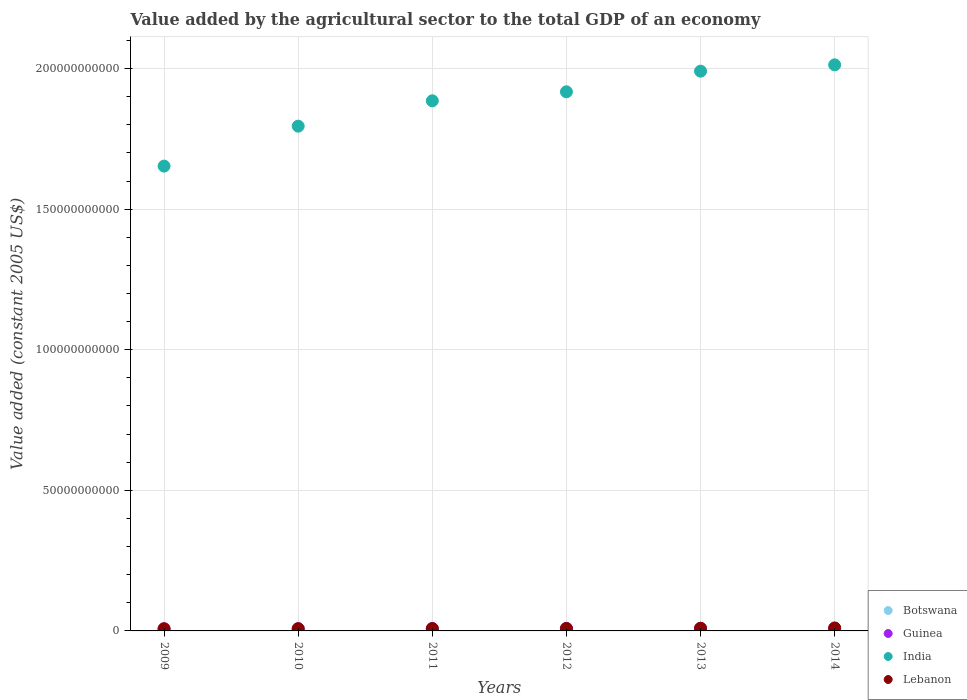How many different coloured dotlines are there?
Offer a terse response. 4. Is the number of dotlines equal to the number of legend labels?
Offer a very short reply. Yes. What is the value added by the agricultural sector in India in 2013?
Offer a very short reply. 1.99e+11. Across all years, what is the maximum value added by the agricultural sector in India?
Offer a very short reply. 2.01e+11. Across all years, what is the minimum value added by the agricultural sector in Guinea?
Make the answer very short. 7.48e+08. In which year was the value added by the agricultural sector in Botswana minimum?
Your response must be concise. 2012. What is the total value added by the agricultural sector in Botswana in the graph?
Provide a short and direct response. 1.52e+09. What is the difference between the value added by the agricultural sector in India in 2010 and that in 2012?
Offer a terse response. -1.22e+1. What is the difference between the value added by the agricultural sector in Botswana in 2011 and the value added by the agricultural sector in Lebanon in 2014?
Your response must be concise. -7.92e+08. What is the average value added by the agricultural sector in Lebanon per year?
Provide a succinct answer. 8.82e+08. In the year 2012, what is the difference between the value added by the agricultural sector in Guinea and value added by the agricultural sector in India?
Provide a short and direct response. -1.91e+11. In how many years, is the value added by the agricultural sector in Guinea greater than 90000000000 US$?
Your answer should be compact. 0. What is the ratio of the value added by the agricultural sector in India in 2011 to that in 2014?
Keep it short and to the point. 0.94. Is the value added by the agricultural sector in Lebanon in 2011 less than that in 2012?
Ensure brevity in your answer.  Yes. Is the difference between the value added by the agricultural sector in Guinea in 2013 and 2014 greater than the difference between the value added by the agricultural sector in India in 2013 and 2014?
Provide a short and direct response. Yes. What is the difference between the highest and the second highest value added by the agricultural sector in Botswana?
Give a very brief answer. 4.64e+05. What is the difference between the highest and the lowest value added by the agricultural sector in Guinea?
Provide a short and direct response. 1.76e+08. Is it the case that in every year, the sum of the value added by the agricultural sector in Guinea and value added by the agricultural sector in India  is greater than the value added by the agricultural sector in Lebanon?
Provide a short and direct response. Yes. Does the value added by the agricultural sector in Lebanon monotonically increase over the years?
Your answer should be very brief. Yes. Is the value added by the agricultural sector in Guinea strictly greater than the value added by the agricultural sector in Botswana over the years?
Offer a very short reply. Yes. How many dotlines are there?
Offer a very short reply. 4. How many years are there in the graph?
Provide a short and direct response. 6. What is the difference between two consecutive major ticks on the Y-axis?
Offer a very short reply. 5.00e+1. Are the values on the major ticks of Y-axis written in scientific E-notation?
Offer a terse response. No. How many legend labels are there?
Your answer should be compact. 4. What is the title of the graph?
Keep it short and to the point. Value added by the agricultural sector to the total GDP of an economy. What is the label or title of the X-axis?
Your answer should be compact. Years. What is the label or title of the Y-axis?
Give a very brief answer. Value added (constant 2005 US$). What is the Value added (constant 2005 US$) of Botswana in 2009?
Your answer should be compact. 2.51e+08. What is the Value added (constant 2005 US$) in Guinea in 2009?
Keep it short and to the point. 7.48e+08. What is the Value added (constant 2005 US$) in India in 2009?
Your answer should be very brief. 1.65e+11. What is the Value added (constant 2005 US$) in Lebanon in 2009?
Offer a terse response. 7.59e+08. What is the Value added (constant 2005 US$) of Botswana in 2010?
Your response must be concise. 2.65e+08. What is the Value added (constant 2005 US$) of Guinea in 2010?
Keep it short and to the point. 7.71e+08. What is the Value added (constant 2005 US$) in India in 2010?
Make the answer very short. 1.80e+11. What is the Value added (constant 2005 US$) in Lebanon in 2010?
Offer a very short reply. 7.92e+08. What is the Value added (constant 2005 US$) of Botswana in 2011?
Keep it short and to the point. 2.66e+08. What is the Value added (constant 2005 US$) of Guinea in 2011?
Your response must be concise. 8.07e+08. What is the Value added (constant 2005 US$) of India in 2011?
Give a very brief answer. 1.89e+11. What is the Value added (constant 2005 US$) of Lebanon in 2011?
Provide a succinct answer. 8.47e+08. What is the Value added (constant 2005 US$) in Botswana in 2012?
Ensure brevity in your answer.  2.43e+08. What is the Value added (constant 2005 US$) of Guinea in 2012?
Your response must be concise. 8.42e+08. What is the Value added (constant 2005 US$) of India in 2012?
Offer a terse response. 1.92e+11. What is the Value added (constant 2005 US$) in Lebanon in 2012?
Provide a succinct answer. 8.88e+08. What is the Value added (constant 2005 US$) in Botswana in 2013?
Give a very brief answer. 2.46e+08. What is the Value added (constant 2005 US$) in Guinea in 2013?
Provide a short and direct response. 9.05e+08. What is the Value added (constant 2005 US$) in India in 2013?
Offer a terse response. 1.99e+11. What is the Value added (constant 2005 US$) in Lebanon in 2013?
Your response must be concise. 9.50e+08. What is the Value added (constant 2005 US$) in Botswana in 2014?
Make the answer very short. 2.45e+08. What is the Value added (constant 2005 US$) in Guinea in 2014?
Provide a succinct answer. 9.24e+08. What is the Value added (constant 2005 US$) of India in 2014?
Offer a terse response. 2.01e+11. What is the Value added (constant 2005 US$) in Lebanon in 2014?
Offer a very short reply. 1.06e+09. Across all years, what is the maximum Value added (constant 2005 US$) in Botswana?
Ensure brevity in your answer.  2.66e+08. Across all years, what is the maximum Value added (constant 2005 US$) of Guinea?
Your response must be concise. 9.24e+08. Across all years, what is the maximum Value added (constant 2005 US$) of India?
Provide a succinct answer. 2.01e+11. Across all years, what is the maximum Value added (constant 2005 US$) of Lebanon?
Your answer should be compact. 1.06e+09. Across all years, what is the minimum Value added (constant 2005 US$) of Botswana?
Provide a short and direct response. 2.43e+08. Across all years, what is the minimum Value added (constant 2005 US$) in Guinea?
Ensure brevity in your answer.  7.48e+08. Across all years, what is the minimum Value added (constant 2005 US$) in India?
Offer a very short reply. 1.65e+11. Across all years, what is the minimum Value added (constant 2005 US$) of Lebanon?
Your answer should be compact. 7.59e+08. What is the total Value added (constant 2005 US$) in Botswana in the graph?
Ensure brevity in your answer.  1.52e+09. What is the total Value added (constant 2005 US$) in Guinea in the graph?
Give a very brief answer. 5.00e+09. What is the total Value added (constant 2005 US$) of India in the graph?
Make the answer very short. 1.13e+12. What is the total Value added (constant 2005 US$) of Lebanon in the graph?
Provide a short and direct response. 5.29e+09. What is the difference between the Value added (constant 2005 US$) in Botswana in 2009 and that in 2010?
Your answer should be very brief. -1.46e+07. What is the difference between the Value added (constant 2005 US$) in Guinea in 2009 and that in 2010?
Offer a terse response. -2.39e+07. What is the difference between the Value added (constant 2005 US$) of India in 2009 and that in 2010?
Offer a terse response. -1.42e+1. What is the difference between the Value added (constant 2005 US$) in Lebanon in 2009 and that in 2010?
Keep it short and to the point. -3.27e+07. What is the difference between the Value added (constant 2005 US$) in Botswana in 2009 and that in 2011?
Ensure brevity in your answer.  -1.50e+07. What is the difference between the Value added (constant 2005 US$) in Guinea in 2009 and that in 2011?
Offer a terse response. -5.98e+07. What is the difference between the Value added (constant 2005 US$) in India in 2009 and that in 2011?
Provide a succinct answer. -2.32e+1. What is the difference between the Value added (constant 2005 US$) of Lebanon in 2009 and that in 2011?
Make the answer very short. -8.83e+07. What is the difference between the Value added (constant 2005 US$) in Botswana in 2009 and that in 2012?
Offer a very short reply. 7.62e+06. What is the difference between the Value added (constant 2005 US$) in Guinea in 2009 and that in 2012?
Give a very brief answer. -9.49e+07. What is the difference between the Value added (constant 2005 US$) of India in 2009 and that in 2012?
Your answer should be compact. -2.64e+1. What is the difference between the Value added (constant 2005 US$) of Lebanon in 2009 and that in 2012?
Your answer should be very brief. -1.29e+08. What is the difference between the Value added (constant 2005 US$) in Botswana in 2009 and that in 2013?
Give a very brief answer. 4.40e+06. What is the difference between the Value added (constant 2005 US$) in Guinea in 2009 and that in 2013?
Ensure brevity in your answer.  -1.57e+08. What is the difference between the Value added (constant 2005 US$) in India in 2009 and that in 2013?
Your answer should be compact. -3.38e+1. What is the difference between the Value added (constant 2005 US$) of Lebanon in 2009 and that in 2013?
Offer a very short reply. -1.91e+08. What is the difference between the Value added (constant 2005 US$) of Botswana in 2009 and that in 2014?
Keep it short and to the point. 5.26e+06. What is the difference between the Value added (constant 2005 US$) of Guinea in 2009 and that in 2014?
Make the answer very short. -1.76e+08. What is the difference between the Value added (constant 2005 US$) of India in 2009 and that in 2014?
Give a very brief answer. -3.60e+1. What is the difference between the Value added (constant 2005 US$) in Lebanon in 2009 and that in 2014?
Give a very brief answer. -2.99e+08. What is the difference between the Value added (constant 2005 US$) in Botswana in 2010 and that in 2011?
Keep it short and to the point. -4.64e+05. What is the difference between the Value added (constant 2005 US$) in Guinea in 2010 and that in 2011?
Your response must be concise. -3.59e+07. What is the difference between the Value added (constant 2005 US$) of India in 2010 and that in 2011?
Your response must be concise. -9.01e+09. What is the difference between the Value added (constant 2005 US$) of Lebanon in 2010 and that in 2011?
Ensure brevity in your answer.  -5.56e+07. What is the difference between the Value added (constant 2005 US$) in Botswana in 2010 and that in 2012?
Offer a very short reply. 2.22e+07. What is the difference between the Value added (constant 2005 US$) in Guinea in 2010 and that in 2012?
Provide a succinct answer. -7.10e+07. What is the difference between the Value added (constant 2005 US$) of India in 2010 and that in 2012?
Your response must be concise. -1.22e+1. What is the difference between the Value added (constant 2005 US$) of Lebanon in 2010 and that in 2012?
Give a very brief answer. -9.65e+07. What is the difference between the Value added (constant 2005 US$) in Botswana in 2010 and that in 2013?
Keep it short and to the point. 1.90e+07. What is the difference between the Value added (constant 2005 US$) in Guinea in 2010 and that in 2013?
Ensure brevity in your answer.  -1.34e+08. What is the difference between the Value added (constant 2005 US$) in India in 2010 and that in 2013?
Keep it short and to the point. -1.96e+1. What is the difference between the Value added (constant 2005 US$) in Lebanon in 2010 and that in 2013?
Offer a very short reply. -1.59e+08. What is the difference between the Value added (constant 2005 US$) in Botswana in 2010 and that in 2014?
Provide a succinct answer. 1.98e+07. What is the difference between the Value added (constant 2005 US$) in Guinea in 2010 and that in 2014?
Make the answer very short. -1.52e+08. What is the difference between the Value added (constant 2005 US$) in India in 2010 and that in 2014?
Provide a succinct answer. -2.18e+1. What is the difference between the Value added (constant 2005 US$) of Lebanon in 2010 and that in 2014?
Your response must be concise. -2.66e+08. What is the difference between the Value added (constant 2005 US$) of Botswana in 2011 and that in 2012?
Offer a very short reply. 2.27e+07. What is the difference between the Value added (constant 2005 US$) of Guinea in 2011 and that in 2012?
Your answer should be very brief. -3.51e+07. What is the difference between the Value added (constant 2005 US$) in India in 2011 and that in 2012?
Give a very brief answer. -3.20e+09. What is the difference between the Value added (constant 2005 US$) of Lebanon in 2011 and that in 2012?
Give a very brief answer. -4.08e+07. What is the difference between the Value added (constant 2005 US$) of Botswana in 2011 and that in 2013?
Give a very brief answer. 1.94e+07. What is the difference between the Value added (constant 2005 US$) of Guinea in 2011 and that in 2013?
Keep it short and to the point. -9.76e+07. What is the difference between the Value added (constant 2005 US$) of India in 2011 and that in 2013?
Keep it short and to the point. -1.05e+1. What is the difference between the Value added (constant 2005 US$) in Lebanon in 2011 and that in 2013?
Offer a very short reply. -1.03e+08. What is the difference between the Value added (constant 2005 US$) of Botswana in 2011 and that in 2014?
Offer a terse response. 2.03e+07. What is the difference between the Value added (constant 2005 US$) in Guinea in 2011 and that in 2014?
Your response must be concise. -1.17e+08. What is the difference between the Value added (constant 2005 US$) of India in 2011 and that in 2014?
Provide a short and direct response. -1.28e+1. What is the difference between the Value added (constant 2005 US$) in Lebanon in 2011 and that in 2014?
Offer a terse response. -2.10e+08. What is the difference between the Value added (constant 2005 US$) in Botswana in 2012 and that in 2013?
Offer a terse response. -3.22e+06. What is the difference between the Value added (constant 2005 US$) of Guinea in 2012 and that in 2013?
Give a very brief answer. -6.25e+07. What is the difference between the Value added (constant 2005 US$) of India in 2012 and that in 2013?
Provide a succinct answer. -7.34e+09. What is the difference between the Value added (constant 2005 US$) in Lebanon in 2012 and that in 2013?
Your answer should be compact. -6.22e+07. What is the difference between the Value added (constant 2005 US$) of Botswana in 2012 and that in 2014?
Your response must be concise. -2.37e+06. What is the difference between the Value added (constant 2005 US$) of Guinea in 2012 and that in 2014?
Offer a very short reply. -8.14e+07. What is the difference between the Value added (constant 2005 US$) of India in 2012 and that in 2014?
Offer a very short reply. -9.59e+09. What is the difference between the Value added (constant 2005 US$) of Lebanon in 2012 and that in 2014?
Provide a succinct answer. -1.69e+08. What is the difference between the Value added (constant 2005 US$) in Botswana in 2013 and that in 2014?
Keep it short and to the point. 8.58e+05. What is the difference between the Value added (constant 2005 US$) in Guinea in 2013 and that in 2014?
Your answer should be compact. -1.89e+07. What is the difference between the Value added (constant 2005 US$) in India in 2013 and that in 2014?
Your response must be concise. -2.25e+09. What is the difference between the Value added (constant 2005 US$) in Lebanon in 2013 and that in 2014?
Provide a succinct answer. -1.07e+08. What is the difference between the Value added (constant 2005 US$) of Botswana in 2009 and the Value added (constant 2005 US$) of Guinea in 2010?
Provide a succinct answer. -5.21e+08. What is the difference between the Value added (constant 2005 US$) in Botswana in 2009 and the Value added (constant 2005 US$) in India in 2010?
Provide a succinct answer. -1.79e+11. What is the difference between the Value added (constant 2005 US$) of Botswana in 2009 and the Value added (constant 2005 US$) of Lebanon in 2010?
Provide a short and direct response. -5.41e+08. What is the difference between the Value added (constant 2005 US$) in Guinea in 2009 and the Value added (constant 2005 US$) in India in 2010?
Make the answer very short. -1.79e+11. What is the difference between the Value added (constant 2005 US$) of Guinea in 2009 and the Value added (constant 2005 US$) of Lebanon in 2010?
Your response must be concise. -4.41e+07. What is the difference between the Value added (constant 2005 US$) of India in 2009 and the Value added (constant 2005 US$) of Lebanon in 2010?
Provide a short and direct response. 1.65e+11. What is the difference between the Value added (constant 2005 US$) of Botswana in 2009 and the Value added (constant 2005 US$) of Guinea in 2011?
Keep it short and to the point. -5.57e+08. What is the difference between the Value added (constant 2005 US$) of Botswana in 2009 and the Value added (constant 2005 US$) of India in 2011?
Your answer should be very brief. -1.88e+11. What is the difference between the Value added (constant 2005 US$) of Botswana in 2009 and the Value added (constant 2005 US$) of Lebanon in 2011?
Provide a short and direct response. -5.97e+08. What is the difference between the Value added (constant 2005 US$) in Guinea in 2009 and the Value added (constant 2005 US$) in India in 2011?
Offer a very short reply. -1.88e+11. What is the difference between the Value added (constant 2005 US$) in Guinea in 2009 and the Value added (constant 2005 US$) in Lebanon in 2011?
Provide a short and direct response. -9.97e+07. What is the difference between the Value added (constant 2005 US$) of India in 2009 and the Value added (constant 2005 US$) of Lebanon in 2011?
Offer a terse response. 1.64e+11. What is the difference between the Value added (constant 2005 US$) in Botswana in 2009 and the Value added (constant 2005 US$) in Guinea in 2012?
Provide a succinct answer. -5.92e+08. What is the difference between the Value added (constant 2005 US$) in Botswana in 2009 and the Value added (constant 2005 US$) in India in 2012?
Offer a terse response. -1.91e+11. What is the difference between the Value added (constant 2005 US$) in Botswana in 2009 and the Value added (constant 2005 US$) in Lebanon in 2012?
Your response must be concise. -6.38e+08. What is the difference between the Value added (constant 2005 US$) of Guinea in 2009 and the Value added (constant 2005 US$) of India in 2012?
Offer a terse response. -1.91e+11. What is the difference between the Value added (constant 2005 US$) in Guinea in 2009 and the Value added (constant 2005 US$) in Lebanon in 2012?
Your answer should be very brief. -1.41e+08. What is the difference between the Value added (constant 2005 US$) in India in 2009 and the Value added (constant 2005 US$) in Lebanon in 2012?
Ensure brevity in your answer.  1.64e+11. What is the difference between the Value added (constant 2005 US$) of Botswana in 2009 and the Value added (constant 2005 US$) of Guinea in 2013?
Keep it short and to the point. -6.54e+08. What is the difference between the Value added (constant 2005 US$) of Botswana in 2009 and the Value added (constant 2005 US$) of India in 2013?
Keep it short and to the point. -1.99e+11. What is the difference between the Value added (constant 2005 US$) in Botswana in 2009 and the Value added (constant 2005 US$) in Lebanon in 2013?
Your answer should be very brief. -7.00e+08. What is the difference between the Value added (constant 2005 US$) of Guinea in 2009 and the Value added (constant 2005 US$) of India in 2013?
Ensure brevity in your answer.  -1.98e+11. What is the difference between the Value added (constant 2005 US$) of Guinea in 2009 and the Value added (constant 2005 US$) of Lebanon in 2013?
Make the answer very short. -2.03e+08. What is the difference between the Value added (constant 2005 US$) in India in 2009 and the Value added (constant 2005 US$) in Lebanon in 2013?
Offer a terse response. 1.64e+11. What is the difference between the Value added (constant 2005 US$) in Botswana in 2009 and the Value added (constant 2005 US$) in Guinea in 2014?
Offer a terse response. -6.73e+08. What is the difference between the Value added (constant 2005 US$) of Botswana in 2009 and the Value added (constant 2005 US$) of India in 2014?
Offer a terse response. -2.01e+11. What is the difference between the Value added (constant 2005 US$) in Botswana in 2009 and the Value added (constant 2005 US$) in Lebanon in 2014?
Your answer should be compact. -8.07e+08. What is the difference between the Value added (constant 2005 US$) of Guinea in 2009 and the Value added (constant 2005 US$) of India in 2014?
Your answer should be very brief. -2.01e+11. What is the difference between the Value added (constant 2005 US$) in Guinea in 2009 and the Value added (constant 2005 US$) in Lebanon in 2014?
Provide a short and direct response. -3.10e+08. What is the difference between the Value added (constant 2005 US$) of India in 2009 and the Value added (constant 2005 US$) of Lebanon in 2014?
Your response must be concise. 1.64e+11. What is the difference between the Value added (constant 2005 US$) in Botswana in 2010 and the Value added (constant 2005 US$) in Guinea in 2011?
Your response must be concise. -5.42e+08. What is the difference between the Value added (constant 2005 US$) in Botswana in 2010 and the Value added (constant 2005 US$) in India in 2011?
Provide a succinct answer. -1.88e+11. What is the difference between the Value added (constant 2005 US$) in Botswana in 2010 and the Value added (constant 2005 US$) in Lebanon in 2011?
Make the answer very short. -5.82e+08. What is the difference between the Value added (constant 2005 US$) in Guinea in 2010 and the Value added (constant 2005 US$) in India in 2011?
Offer a very short reply. -1.88e+11. What is the difference between the Value added (constant 2005 US$) in Guinea in 2010 and the Value added (constant 2005 US$) in Lebanon in 2011?
Your answer should be compact. -7.58e+07. What is the difference between the Value added (constant 2005 US$) in India in 2010 and the Value added (constant 2005 US$) in Lebanon in 2011?
Your response must be concise. 1.79e+11. What is the difference between the Value added (constant 2005 US$) of Botswana in 2010 and the Value added (constant 2005 US$) of Guinea in 2012?
Offer a terse response. -5.77e+08. What is the difference between the Value added (constant 2005 US$) in Botswana in 2010 and the Value added (constant 2005 US$) in India in 2012?
Provide a short and direct response. -1.91e+11. What is the difference between the Value added (constant 2005 US$) in Botswana in 2010 and the Value added (constant 2005 US$) in Lebanon in 2012?
Offer a terse response. -6.23e+08. What is the difference between the Value added (constant 2005 US$) of Guinea in 2010 and the Value added (constant 2005 US$) of India in 2012?
Your answer should be very brief. -1.91e+11. What is the difference between the Value added (constant 2005 US$) of Guinea in 2010 and the Value added (constant 2005 US$) of Lebanon in 2012?
Give a very brief answer. -1.17e+08. What is the difference between the Value added (constant 2005 US$) in India in 2010 and the Value added (constant 2005 US$) in Lebanon in 2012?
Your response must be concise. 1.79e+11. What is the difference between the Value added (constant 2005 US$) of Botswana in 2010 and the Value added (constant 2005 US$) of Guinea in 2013?
Offer a terse response. -6.40e+08. What is the difference between the Value added (constant 2005 US$) in Botswana in 2010 and the Value added (constant 2005 US$) in India in 2013?
Provide a short and direct response. -1.99e+11. What is the difference between the Value added (constant 2005 US$) in Botswana in 2010 and the Value added (constant 2005 US$) in Lebanon in 2013?
Your answer should be compact. -6.85e+08. What is the difference between the Value added (constant 2005 US$) of Guinea in 2010 and the Value added (constant 2005 US$) of India in 2013?
Ensure brevity in your answer.  -1.98e+11. What is the difference between the Value added (constant 2005 US$) in Guinea in 2010 and the Value added (constant 2005 US$) in Lebanon in 2013?
Offer a very short reply. -1.79e+08. What is the difference between the Value added (constant 2005 US$) of India in 2010 and the Value added (constant 2005 US$) of Lebanon in 2013?
Provide a succinct answer. 1.79e+11. What is the difference between the Value added (constant 2005 US$) of Botswana in 2010 and the Value added (constant 2005 US$) of Guinea in 2014?
Ensure brevity in your answer.  -6.59e+08. What is the difference between the Value added (constant 2005 US$) of Botswana in 2010 and the Value added (constant 2005 US$) of India in 2014?
Your answer should be very brief. -2.01e+11. What is the difference between the Value added (constant 2005 US$) of Botswana in 2010 and the Value added (constant 2005 US$) of Lebanon in 2014?
Your response must be concise. -7.92e+08. What is the difference between the Value added (constant 2005 US$) of Guinea in 2010 and the Value added (constant 2005 US$) of India in 2014?
Your answer should be very brief. -2.01e+11. What is the difference between the Value added (constant 2005 US$) of Guinea in 2010 and the Value added (constant 2005 US$) of Lebanon in 2014?
Offer a very short reply. -2.86e+08. What is the difference between the Value added (constant 2005 US$) in India in 2010 and the Value added (constant 2005 US$) in Lebanon in 2014?
Provide a short and direct response. 1.78e+11. What is the difference between the Value added (constant 2005 US$) of Botswana in 2011 and the Value added (constant 2005 US$) of Guinea in 2012?
Ensure brevity in your answer.  -5.77e+08. What is the difference between the Value added (constant 2005 US$) in Botswana in 2011 and the Value added (constant 2005 US$) in India in 2012?
Your answer should be compact. -1.91e+11. What is the difference between the Value added (constant 2005 US$) in Botswana in 2011 and the Value added (constant 2005 US$) in Lebanon in 2012?
Keep it short and to the point. -6.23e+08. What is the difference between the Value added (constant 2005 US$) of Guinea in 2011 and the Value added (constant 2005 US$) of India in 2012?
Your answer should be very brief. -1.91e+11. What is the difference between the Value added (constant 2005 US$) of Guinea in 2011 and the Value added (constant 2005 US$) of Lebanon in 2012?
Give a very brief answer. -8.08e+07. What is the difference between the Value added (constant 2005 US$) in India in 2011 and the Value added (constant 2005 US$) in Lebanon in 2012?
Give a very brief answer. 1.88e+11. What is the difference between the Value added (constant 2005 US$) of Botswana in 2011 and the Value added (constant 2005 US$) of Guinea in 2013?
Give a very brief answer. -6.39e+08. What is the difference between the Value added (constant 2005 US$) of Botswana in 2011 and the Value added (constant 2005 US$) of India in 2013?
Make the answer very short. -1.99e+11. What is the difference between the Value added (constant 2005 US$) in Botswana in 2011 and the Value added (constant 2005 US$) in Lebanon in 2013?
Make the answer very short. -6.85e+08. What is the difference between the Value added (constant 2005 US$) of Guinea in 2011 and the Value added (constant 2005 US$) of India in 2013?
Your response must be concise. -1.98e+11. What is the difference between the Value added (constant 2005 US$) of Guinea in 2011 and the Value added (constant 2005 US$) of Lebanon in 2013?
Make the answer very short. -1.43e+08. What is the difference between the Value added (constant 2005 US$) of India in 2011 and the Value added (constant 2005 US$) of Lebanon in 2013?
Your response must be concise. 1.88e+11. What is the difference between the Value added (constant 2005 US$) in Botswana in 2011 and the Value added (constant 2005 US$) in Guinea in 2014?
Offer a terse response. -6.58e+08. What is the difference between the Value added (constant 2005 US$) of Botswana in 2011 and the Value added (constant 2005 US$) of India in 2014?
Make the answer very short. -2.01e+11. What is the difference between the Value added (constant 2005 US$) in Botswana in 2011 and the Value added (constant 2005 US$) in Lebanon in 2014?
Your answer should be very brief. -7.92e+08. What is the difference between the Value added (constant 2005 US$) of Guinea in 2011 and the Value added (constant 2005 US$) of India in 2014?
Your answer should be compact. -2.01e+11. What is the difference between the Value added (constant 2005 US$) of Guinea in 2011 and the Value added (constant 2005 US$) of Lebanon in 2014?
Your answer should be compact. -2.50e+08. What is the difference between the Value added (constant 2005 US$) in India in 2011 and the Value added (constant 2005 US$) in Lebanon in 2014?
Offer a terse response. 1.87e+11. What is the difference between the Value added (constant 2005 US$) of Botswana in 2012 and the Value added (constant 2005 US$) of Guinea in 2013?
Provide a succinct answer. -6.62e+08. What is the difference between the Value added (constant 2005 US$) of Botswana in 2012 and the Value added (constant 2005 US$) of India in 2013?
Make the answer very short. -1.99e+11. What is the difference between the Value added (constant 2005 US$) in Botswana in 2012 and the Value added (constant 2005 US$) in Lebanon in 2013?
Your response must be concise. -7.07e+08. What is the difference between the Value added (constant 2005 US$) of Guinea in 2012 and the Value added (constant 2005 US$) of India in 2013?
Provide a short and direct response. -1.98e+11. What is the difference between the Value added (constant 2005 US$) of Guinea in 2012 and the Value added (constant 2005 US$) of Lebanon in 2013?
Offer a terse response. -1.08e+08. What is the difference between the Value added (constant 2005 US$) in India in 2012 and the Value added (constant 2005 US$) in Lebanon in 2013?
Your response must be concise. 1.91e+11. What is the difference between the Value added (constant 2005 US$) in Botswana in 2012 and the Value added (constant 2005 US$) in Guinea in 2014?
Your answer should be very brief. -6.81e+08. What is the difference between the Value added (constant 2005 US$) in Botswana in 2012 and the Value added (constant 2005 US$) in India in 2014?
Provide a succinct answer. -2.01e+11. What is the difference between the Value added (constant 2005 US$) of Botswana in 2012 and the Value added (constant 2005 US$) of Lebanon in 2014?
Provide a succinct answer. -8.15e+08. What is the difference between the Value added (constant 2005 US$) in Guinea in 2012 and the Value added (constant 2005 US$) in India in 2014?
Provide a short and direct response. -2.00e+11. What is the difference between the Value added (constant 2005 US$) in Guinea in 2012 and the Value added (constant 2005 US$) in Lebanon in 2014?
Provide a short and direct response. -2.15e+08. What is the difference between the Value added (constant 2005 US$) in India in 2012 and the Value added (constant 2005 US$) in Lebanon in 2014?
Your response must be concise. 1.91e+11. What is the difference between the Value added (constant 2005 US$) of Botswana in 2013 and the Value added (constant 2005 US$) of Guinea in 2014?
Your response must be concise. -6.78e+08. What is the difference between the Value added (constant 2005 US$) in Botswana in 2013 and the Value added (constant 2005 US$) in India in 2014?
Your answer should be very brief. -2.01e+11. What is the difference between the Value added (constant 2005 US$) of Botswana in 2013 and the Value added (constant 2005 US$) of Lebanon in 2014?
Your answer should be very brief. -8.11e+08. What is the difference between the Value added (constant 2005 US$) in Guinea in 2013 and the Value added (constant 2005 US$) in India in 2014?
Keep it short and to the point. -2.00e+11. What is the difference between the Value added (constant 2005 US$) of Guinea in 2013 and the Value added (constant 2005 US$) of Lebanon in 2014?
Provide a short and direct response. -1.53e+08. What is the difference between the Value added (constant 2005 US$) of India in 2013 and the Value added (constant 2005 US$) of Lebanon in 2014?
Give a very brief answer. 1.98e+11. What is the average Value added (constant 2005 US$) of Botswana per year?
Give a very brief answer. 2.53e+08. What is the average Value added (constant 2005 US$) of Guinea per year?
Make the answer very short. 8.33e+08. What is the average Value added (constant 2005 US$) in India per year?
Keep it short and to the point. 1.88e+11. What is the average Value added (constant 2005 US$) in Lebanon per year?
Your answer should be very brief. 8.82e+08. In the year 2009, what is the difference between the Value added (constant 2005 US$) in Botswana and Value added (constant 2005 US$) in Guinea?
Your answer should be compact. -4.97e+08. In the year 2009, what is the difference between the Value added (constant 2005 US$) of Botswana and Value added (constant 2005 US$) of India?
Your response must be concise. -1.65e+11. In the year 2009, what is the difference between the Value added (constant 2005 US$) in Botswana and Value added (constant 2005 US$) in Lebanon?
Ensure brevity in your answer.  -5.08e+08. In the year 2009, what is the difference between the Value added (constant 2005 US$) in Guinea and Value added (constant 2005 US$) in India?
Provide a succinct answer. -1.65e+11. In the year 2009, what is the difference between the Value added (constant 2005 US$) of Guinea and Value added (constant 2005 US$) of Lebanon?
Offer a terse response. -1.14e+07. In the year 2009, what is the difference between the Value added (constant 2005 US$) in India and Value added (constant 2005 US$) in Lebanon?
Give a very brief answer. 1.65e+11. In the year 2010, what is the difference between the Value added (constant 2005 US$) in Botswana and Value added (constant 2005 US$) in Guinea?
Your response must be concise. -5.06e+08. In the year 2010, what is the difference between the Value added (constant 2005 US$) in Botswana and Value added (constant 2005 US$) in India?
Your answer should be compact. -1.79e+11. In the year 2010, what is the difference between the Value added (constant 2005 US$) in Botswana and Value added (constant 2005 US$) in Lebanon?
Make the answer very short. -5.27e+08. In the year 2010, what is the difference between the Value added (constant 2005 US$) in Guinea and Value added (constant 2005 US$) in India?
Provide a short and direct response. -1.79e+11. In the year 2010, what is the difference between the Value added (constant 2005 US$) of Guinea and Value added (constant 2005 US$) of Lebanon?
Provide a succinct answer. -2.02e+07. In the year 2010, what is the difference between the Value added (constant 2005 US$) of India and Value added (constant 2005 US$) of Lebanon?
Provide a succinct answer. 1.79e+11. In the year 2011, what is the difference between the Value added (constant 2005 US$) of Botswana and Value added (constant 2005 US$) of Guinea?
Your answer should be very brief. -5.42e+08. In the year 2011, what is the difference between the Value added (constant 2005 US$) of Botswana and Value added (constant 2005 US$) of India?
Ensure brevity in your answer.  -1.88e+11. In the year 2011, what is the difference between the Value added (constant 2005 US$) of Botswana and Value added (constant 2005 US$) of Lebanon?
Your answer should be compact. -5.82e+08. In the year 2011, what is the difference between the Value added (constant 2005 US$) of Guinea and Value added (constant 2005 US$) of India?
Your answer should be very brief. -1.88e+11. In the year 2011, what is the difference between the Value added (constant 2005 US$) in Guinea and Value added (constant 2005 US$) in Lebanon?
Make the answer very short. -3.99e+07. In the year 2011, what is the difference between the Value added (constant 2005 US$) of India and Value added (constant 2005 US$) of Lebanon?
Give a very brief answer. 1.88e+11. In the year 2012, what is the difference between the Value added (constant 2005 US$) in Botswana and Value added (constant 2005 US$) in Guinea?
Your answer should be very brief. -6.00e+08. In the year 2012, what is the difference between the Value added (constant 2005 US$) in Botswana and Value added (constant 2005 US$) in India?
Provide a succinct answer. -1.91e+11. In the year 2012, what is the difference between the Value added (constant 2005 US$) of Botswana and Value added (constant 2005 US$) of Lebanon?
Provide a short and direct response. -6.45e+08. In the year 2012, what is the difference between the Value added (constant 2005 US$) in Guinea and Value added (constant 2005 US$) in India?
Provide a succinct answer. -1.91e+11. In the year 2012, what is the difference between the Value added (constant 2005 US$) in Guinea and Value added (constant 2005 US$) in Lebanon?
Your response must be concise. -4.57e+07. In the year 2012, what is the difference between the Value added (constant 2005 US$) in India and Value added (constant 2005 US$) in Lebanon?
Your answer should be compact. 1.91e+11. In the year 2013, what is the difference between the Value added (constant 2005 US$) of Botswana and Value added (constant 2005 US$) of Guinea?
Make the answer very short. -6.59e+08. In the year 2013, what is the difference between the Value added (constant 2005 US$) in Botswana and Value added (constant 2005 US$) in India?
Keep it short and to the point. -1.99e+11. In the year 2013, what is the difference between the Value added (constant 2005 US$) of Botswana and Value added (constant 2005 US$) of Lebanon?
Give a very brief answer. -7.04e+08. In the year 2013, what is the difference between the Value added (constant 2005 US$) of Guinea and Value added (constant 2005 US$) of India?
Provide a short and direct response. -1.98e+11. In the year 2013, what is the difference between the Value added (constant 2005 US$) in Guinea and Value added (constant 2005 US$) in Lebanon?
Your response must be concise. -4.53e+07. In the year 2013, what is the difference between the Value added (constant 2005 US$) of India and Value added (constant 2005 US$) of Lebanon?
Your answer should be compact. 1.98e+11. In the year 2014, what is the difference between the Value added (constant 2005 US$) in Botswana and Value added (constant 2005 US$) in Guinea?
Give a very brief answer. -6.79e+08. In the year 2014, what is the difference between the Value added (constant 2005 US$) in Botswana and Value added (constant 2005 US$) in India?
Offer a terse response. -2.01e+11. In the year 2014, what is the difference between the Value added (constant 2005 US$) in Botswana and Value added (constant 2005 US$) in Lebanon?
Your answer should be compact. -8.12e+08. In the year 2014, what is the difference between the Value added (constant 2005 US$) in Guinea and Value added (constant 2005 US$) in India?
Offer a very short reply. -2.00e+11. In the year 2014, what is the difference between the Value added (constant 2005 US$) of Guinea and Value added (constant 2005 US$) of Lebanon?
Provide a succinct answer. -1.34e+08. In the year 2014, what is the difference between the Value added (constant 2005 US$) of India and Value added (constant 2005 US$) of Lebanon?
Keep it short and to the point. 2.00e+11. What is the ratio of the Value added (constant 2005 US$) of Botswana in 2009 to that in 2010?
Offer a very short reply. 0.94. What is the ratio of the Value added (constant 2005 US$) of Guinea in 2009 to that in 2010?
Make the answer very short. 0.97. What is the ratio of the Value added (constant 2005 US$) of India in 2009 to that in 2010?
Your answer should be compact. 0.92. What is the ratio of the Value added (constant 2005 US$) in Lebanon in 2009 to that in 2010?
Provide a succinct answer. 0.96. What is the ratio of the Value added (constant 2005 US$) of Botswana in 2009 to that in 2011?
Offer a very short reply. 0.94. What is the ratio of the Value added (constant 2005 US$) in Guinea in 2009 to that in 2011?
Give a very brief answer. 0.93. What is the ratio of the Value added (constant 2005 US$) of India in 2009 to that in 2011?
Make the answer very short. 0.88. What is the ratio of the Value added (constant 2005 US$) in Lebanon in 2009 to that in 2011?
Provide a short and direct response. 0.9. What is the ratio of the Value added (constant 2005 US$) of Botswana in 2009 to that in 2012?
Provide a succinct answer. 1.03. What is the ratio of the Value added (constant 2005 US$) of Guinea in 2009 to that in 2012?
Ensure brevity in your answer.  0.89. What is the ratio of the Value added (constant 2005 US$) in India in 2009 to that in 2012?
Make the answer very short. 0.86. What is the ratio of the Value added (constant 2005 US$) in Lebanon in 2009 to that in 2012?
Offer a terse response. 0.85. What is the ratio of the Value added (constant 2005 US$) of Botswana in 2009 to that in 2013?
Make the answer very short. 1.02. What is the ratio of the Value added (constant 2005 US$) of Guinea in 2009 to that in 2013?
Make the answer very short. 0.83. What is the ratio of the Value added (constant 2005 US$) of India in 2009 to that in 2013?
Ensure brevity in your answer.  0.83. What is the ratio of the Value added (constant 2005 US$) in Lebanon in 2009 to that in 2013?
Your answer should be compact. 0.8. What is the ratio of the Value added (constant 2005 US$) of Botswana in 2009 to that in 2014?
Provide a short and direct response. 1.02. What is the ratio of the Value added (constant 2005 US$) in Guinea in 2009 to that in 2014?
Keep it short and to the point. 0.81. What is the ratio of the Value added (constant 2005 US$) of India in 2009 to that in 2014?
Provide a short and direct response. 0.82. What is the ratio of the Value added (constant 2005 US$) in Lebanon in 2009 to that in 2014?
Give a very brief answer. 0.72. What is the ratio of the Value added (constant 2005 US$) in Botswana in 2010 to that in 2011?
Offer a very short reply. 1. What is the ratio of the Value added (constant 2005 US$) of Guinea in 2010 to that in 2011?
Offer a very short reply. 0.96. What is the ratio of the Value added (constant 2005 US$) in India in 2010 to that in 2011?
Offer a terse response. 0.95. What is the ratio of the Value added (constant 2005 US$) in Lebanon in 2010 to that in 2011?
Provide a succinct answer. 0.93. What is the ratio of the Value added (constant 2005 US$) in Botswana in 2010 to that in 2012?
Your answer should be very brief. 1.09. What is the ratio of the Value added (constant 2005 US$) of Guinea in 2010 to that in 2012?
Provide a succinct answer. 0.92. What is the ratio of the Value added (constant 2005 US$) in India in 2010 to that in 2012?
Keep it short and to the point. 0.94. What is the ratio of the Value added (constant 2005 US$) in Lebanon in 2010 to that in 2012?
Make the answer very short. 0.89. What is the ratio of the Value added (constant 2005 US$) of Botswana in 2010 to that in 2013?
Your answer should be very brief. 1.08. What is the ratio of the Value added (constant 2005 US$) of Guinea in 2010 to that in 2013?
Your answer should be very brief. 0.85. What is the ratio of the Value added (constant 2005 US$) of India in 2010 to that in 2013?
Provide a short and direct response. 0.9. What is the ratio of the Value added (constant 2005 US$) of Lebanon in 2010 to that in 2013?
Keep it short and to the point. 0.83. What is the ratio of the Value added (constant 2005 US$) in Botswana in 2010 to that in 2014?
Provide a short and direct response. 1.08. What is the ratio of the Value added (constant 2005 US$) of Guinea in 2010 to that in 2014?
Give a very brief answer. 0.83. What is the ratio of the Value added (constant 2005 US$) of India in 2010 to that in 2014?
Provide a succinct answer. 0.89. What is the ratio of the Value added (constant 2005 US$) in Lebanon in 2010 to that in 2014?
Your response must be concise. 0.75. What is the ratio of the Value added (constant 2005 US$) of Botswana in 2011 to that in 2012?
Offer a terse response. 1.09. What is the ratio of the Value added (constant 2005 US$) of India in 2011 to that in 2012?
Your answer should be very brief. 0.98. What is the ratio of the Value added (constant 2005 US$) of Lebanon in 2011 to that in 2012?
Your answer should be compact. 0.95. What is the ratio of the Value added (constant 2005 US$) of Botswana in 2011 to that in 2013?
Your answer should be very brief. 1.08. What is the ratio of the Value added (constant 2005 US$) in Guinea in 2011 to that in 2013?
Provide a succinct answer. 0.89. What is the ratio of the Value added (constant 2005 US$) in India in 2011 to that in 2013?
Provide a short and direct response. 0.95. What is the ratio of the Value added (constant 2005 US$) of Lebanon in 2011 to that in 2013?
Offer a very short reply. 0.89. What is the ratio of the Value added (constant 2005 US$) of Botswana in 2011 to that in 2014?
Provide a short and direct response. 1.08. What is the ratio of the Value added (constant 2005 US$) in Guinea in 2011 to that in 2014?
Provide a succinct answer. 0.87. What is the ratio of the Value added (constant 2005 US$) in India in 2011 to that in 2014?
Your answer should be very brief. 0.94. What is the ratio of the Value added (constant 2005 US$) of Lebanon in 2011 to that in 2014?
Your answer should be very brief. 0.8. What is the ratio of the Value added (constant 2005 US$) of Botswana in 2012 to that in 2013?
Provide a succinct answer. 0.99. What is the ratio of the Value added (constant 2005 US$) in Guinea in 2012 to that in 2013?
Offer a terse response. 0.93. What is the ratio of the Value added (constant 2005 US$) of India in 2012 to that in 2013?
Keep it short and to the point. 0.96. What is the ratio of the Value added (constant 2005 US$) in Lebanon in 2012 to that in 2013?
Offer a terse response. 0.93. What is the ratio of the Value added (constant 2005 US$) in Guinea in 2012 to that in 2014?
Your answer should be compact. 0.91. What is the ratio of the Value added (constant 2005 US$) in Lebanon in 2012 to that in 2014?
Provide a short and direct response. 0.84. What is the ratio of the Value added (constant 2005 US$) in Botswana in 2013 to that in 2014?
Provide a short and direct response. 1. What is the ratio of the Value added (constant 2005 US$) in Guinea in 2013 to that in 2014?
Ensure brevity in your answer.  0.98. What is the ratio of the Value added (constant 2005 US$) in Lebanon in 2013 to that in 2014?
Offer a very short reply. 0.9. What is the difference between the highest and the second highest Value added (constant 2005 US$) in Botswana?
Your answer should be compact. 4.64e+05. What is the difference between the highest and the second highest Value added (constant 2005 US$) in Guinea?
Offer a terse response. 1.89e+07. What is the difference between the highest and the second highest Value added (constant 2005 US$) in India?
Keep it short and to the point. 2.25e+09. What is the difference between the highest and the second highest Value added (constant 2005 US$) of Lebanon?
Offer a terse response. 1.07e+08. What is the difference between the highest and the lowest Value added (constant 2005 US$) in Botswana?
Keep it short and to the point. 2.27e+07. What is the difference between the highest and the lowest Value added (constant 2005 US$) in Guinea?
Ensure brevity in your answer.  1.76e+08. What is the difference between the highest and the lowest Value added (constant 2005 US$) of India?
Offer a terse response. 3.60e+1. What is the difference between the highest and the lowest Value added (constant 2005 US$) of Lebanon?
Make the answer very short. 2.99e+08. 